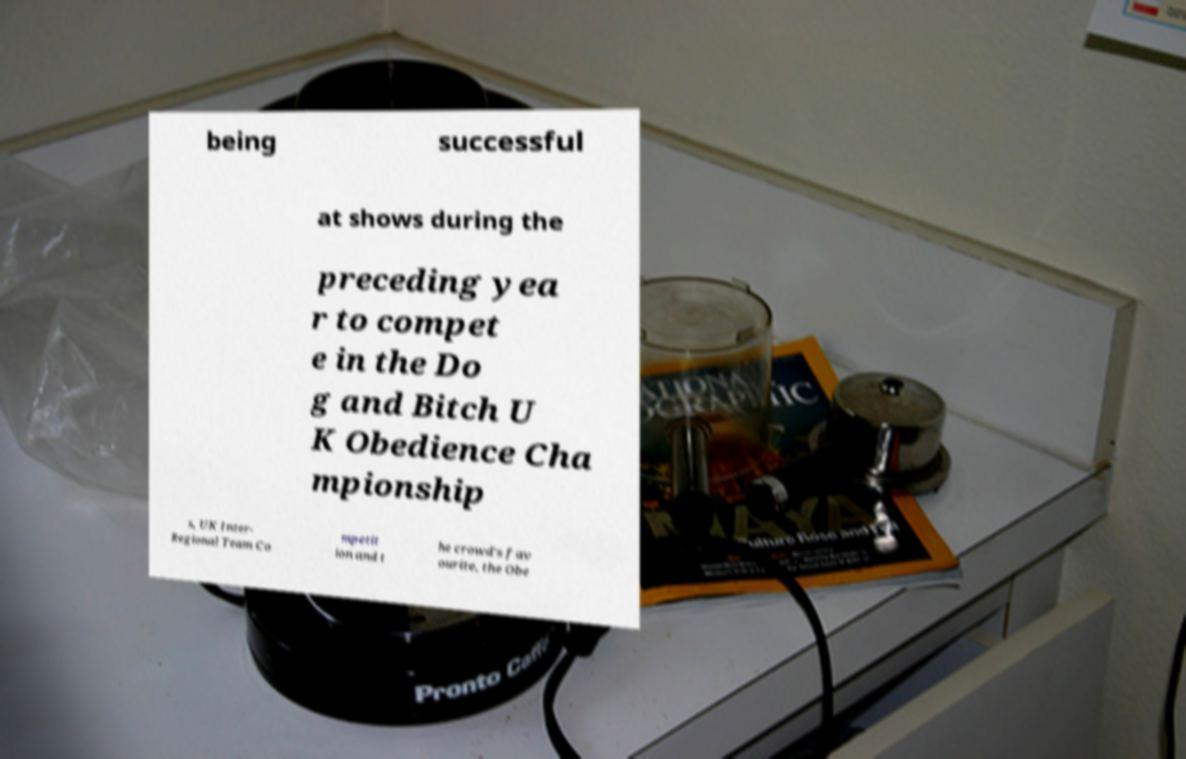Can you accurately transcribe the text from the provided image for me? being successful at shows during the preceding yea r to compet e in the Do g and Bitch U K Obedience Cha mpionship s, UK Inter- Regional Team Co mpetit ion and t he crowd's fav ourite, the Obe 